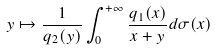Convert formula to latex. <formula><loc_0><loc_0><loc_500><loc_500>y \mapsto \frac { 1 } { q _ { 2 } ( y ) } \int _ { 0 } ^ { + \infty } \frac { q _ { 1 } ( x ) } { x + y } d \sigma ( x )</formula> 